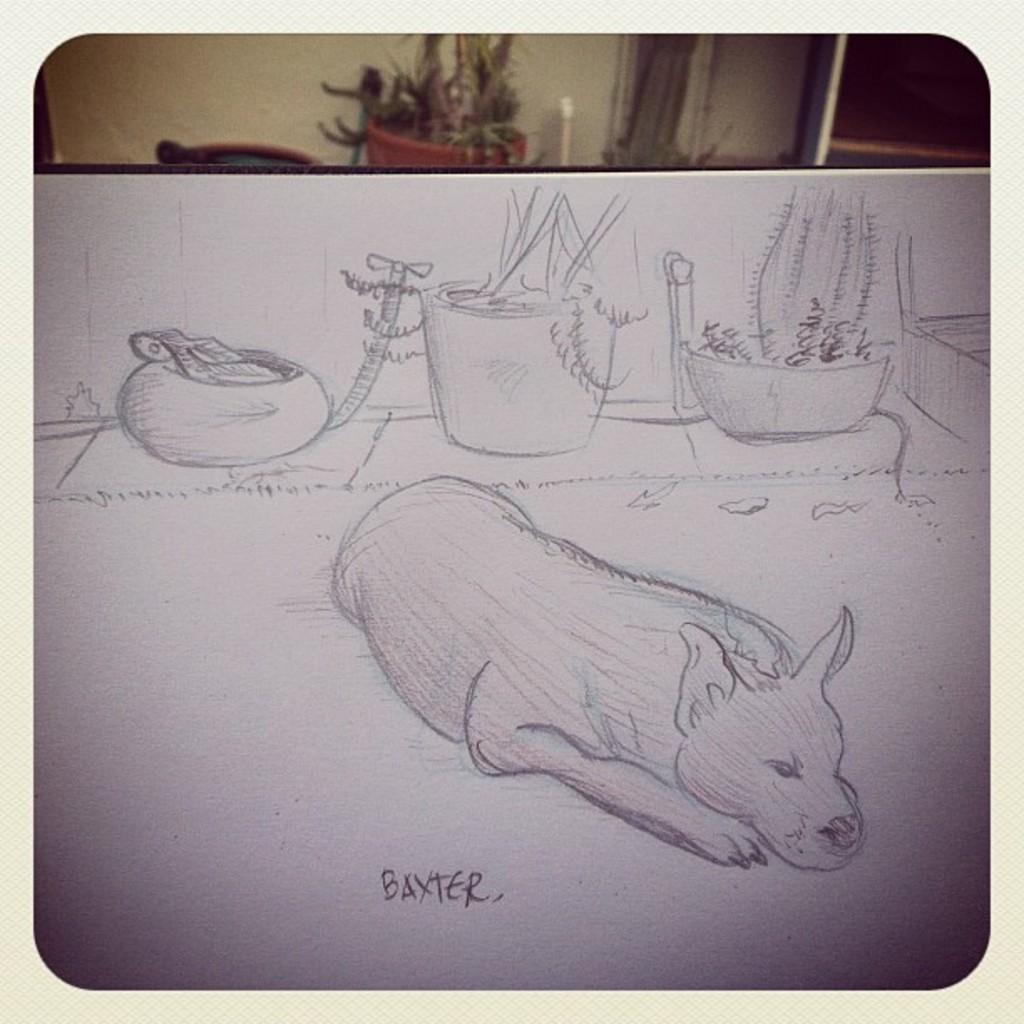Describe this image in one or two sentences. In this picture, we can see a sketch and some text on the white surface, in the background we can see the wall, plant in a pot, pipe, and some objects. 